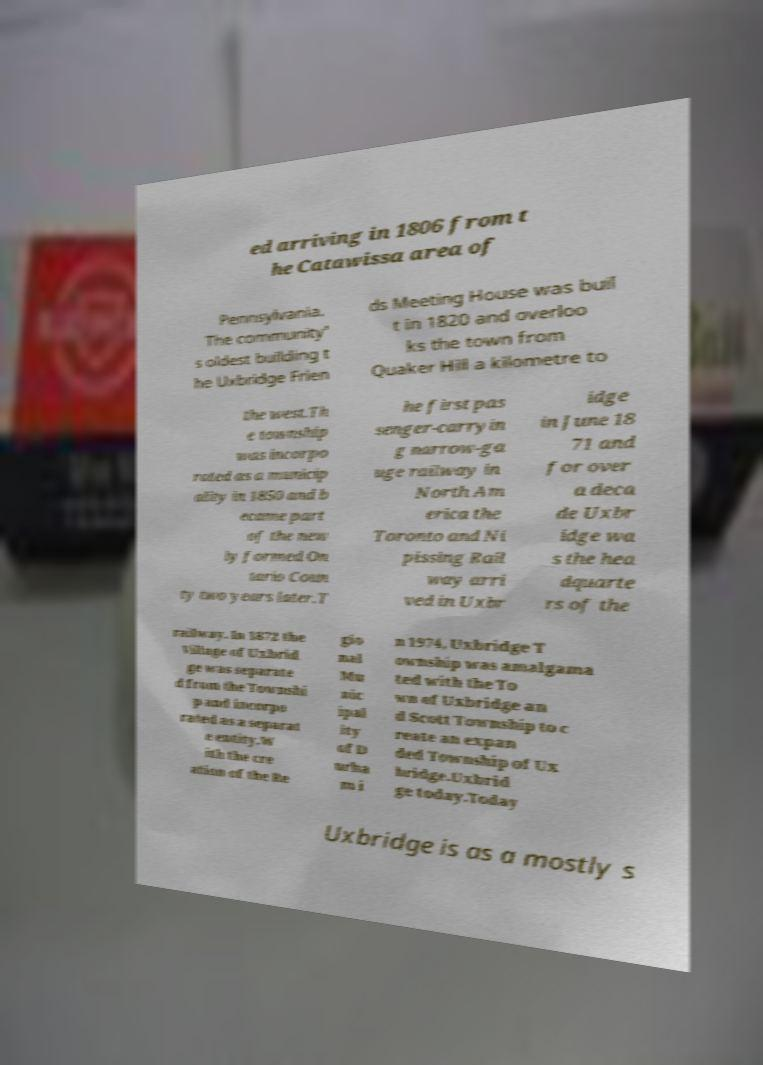Could you extract and type out the text from this image? ed arriving in 1806 from t he Catawissa area of Pennsylvania. The community' s oldest building t he Uxbridge Frien ds Meeting House was buil t in 1820 and overloo ks the town from Quaker Hill a kilometre to the west.Th e township was incorpo rated as a municip ality in 1850 and b ecame part of the new ly formed On tario Coun ty two years later.T he first pas senger-carryin g narrow-ga uge railway in North Am erica the Toronto and Ni pissing Rail way arri ved in Uxbr idge in June 18 71 and for over a deca de Uxbr idge wa s the hea dquarte rs of the railway. In 1872 the Village of Uxbrid ge was separate d from the Townshi p and incorpo rated as a separat e entity.W ith the cre ation of the Re gio nal Mu nic ipal ity of D urha m i n 1974, Uxbridge T ownship was amalgama ted with the To wn of Uxbridge an d Scott Township to c reate an expan ded Township of Ux bridge.Uxbrid ge today.Today Uxbridge is as a mostly s 